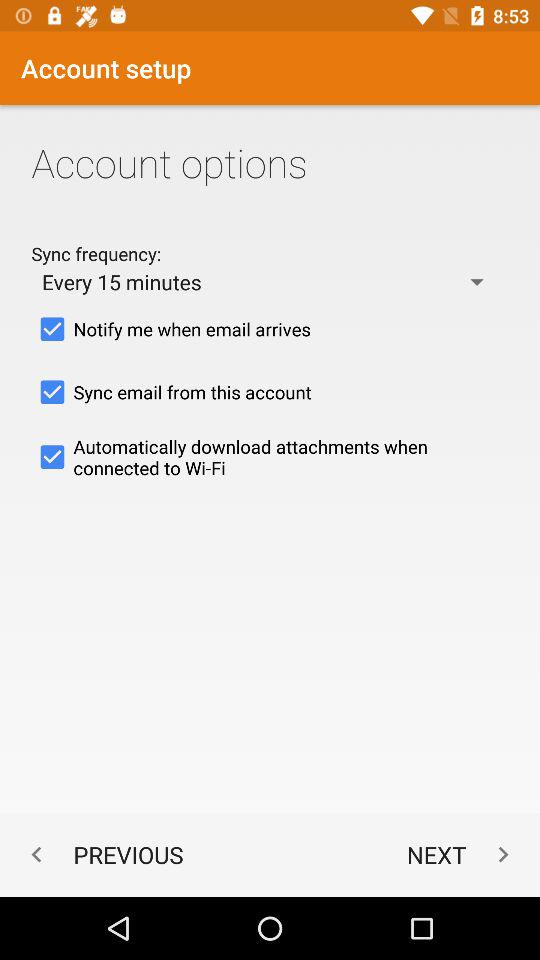How many options are there for syncing email?
Answer the question using a single word or phrase. 3 